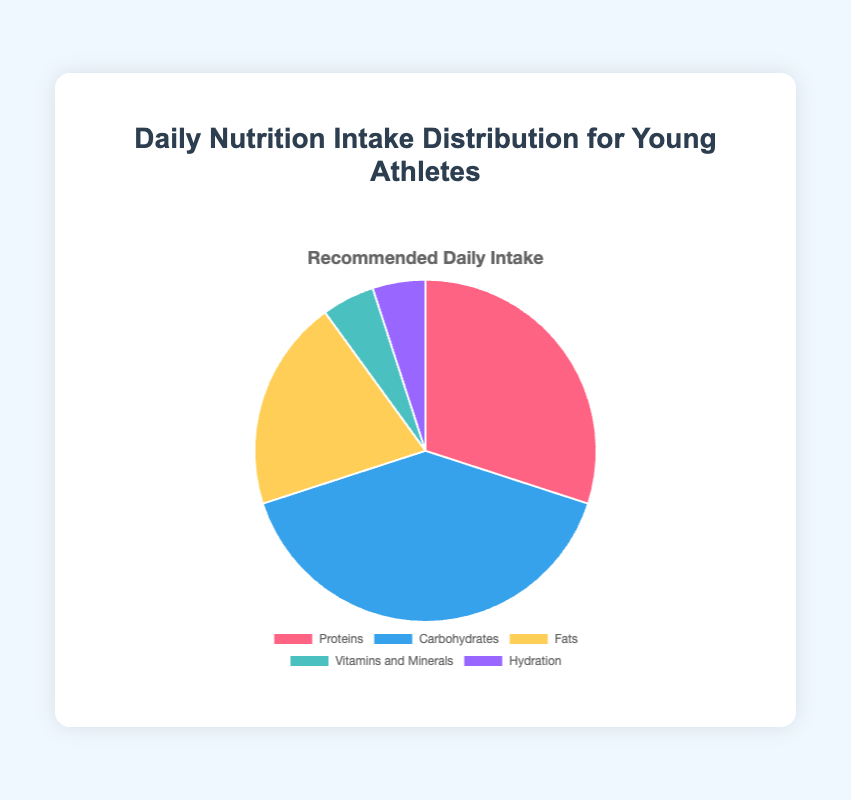What's the largest category in the daily nutrition intake? From the pie chart, the largest segment is for "Carbohydrates" with a 40% share, which visually stands out as the largest colored section.
Answer: Carbohydrates What is the combined percentage of Proteins and Fats? Add the percentages of Proteins (30%) and Fats (20%). So, 30% + 20% = 50%.
Answer: 50% How does the percentage of Hydration intake compare to the percentage of Vitamins and Minerals intake? Hydration and Vitamins and Minerals each make up 5% of the daily intake, shown as equal-sized segments in the pie chart.
Answer: Equal Which category has the smallest percentage of intake? The categories with the smallest percentages are Hydration and Vitamins and Minerals, both at 5%.
Answer: Hydration and Vitamins and Minerals Is the percentage of Carbohydrates intake greater than the sum of Fats and Proteins? The percentage of Carbohydrates is 40%. The sum of Fats (20%) and Proteins (30%) is 50%, which is greater than 40%.
Answer: No What fraction of the pie chart is composed of Proteins? Proteins make up 30% of the pie chart, which corresponds to 3/10 of the chart.
Answer: 3/10 Compare the intake percentages of Fats and Carbohydrates. Which is higher and by how much? Carbohydrates have a higher intake at 40%, while Fats are at 20%. The difference is 40% - 20% = 20%.
Answer: Carbohydrates by 20% What is the total percentage for non-macronutrient categories (Vitamins and Minerals, Hydration)? Add the percentages of Vitamins and Minerals (5%) and Hydration (5%). So, 5% + 5% = 10%.
Answer: 10% If you were to increase the intake of Fats by 10%, what would the new percentage be? The current intake percentage of Fats is 20%. Increasing by 10% would result in 20% + 10% = 30%.
Answer: 30% What is the difference between the highest and the lowest category percentages? The highest category is Carbohydrates (40%), and the lowest categories are Hydration and Vitamins and Minerals (5%). The difference is 40% - 5% = 35%.
Answer: 35% 